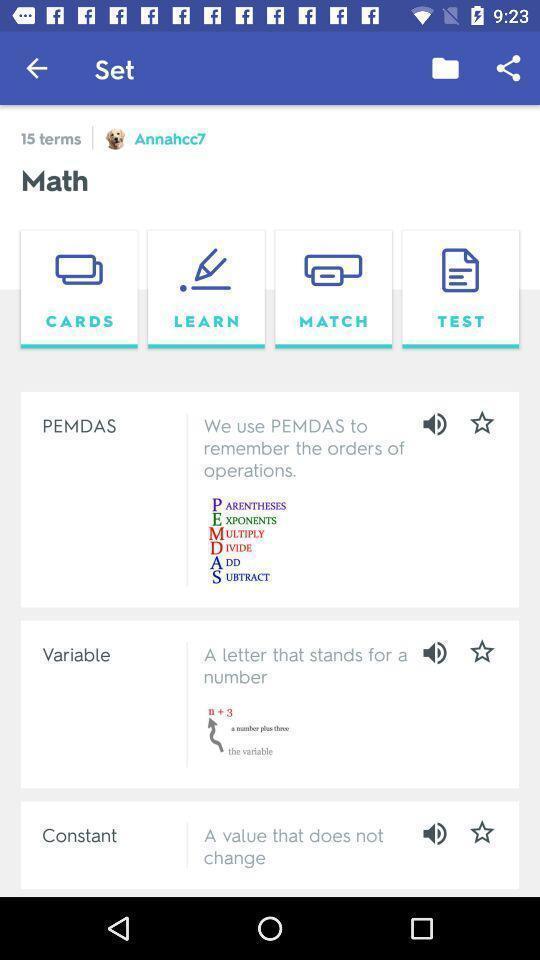Describe the key features of this screenshot. Window displaying a learning app. 